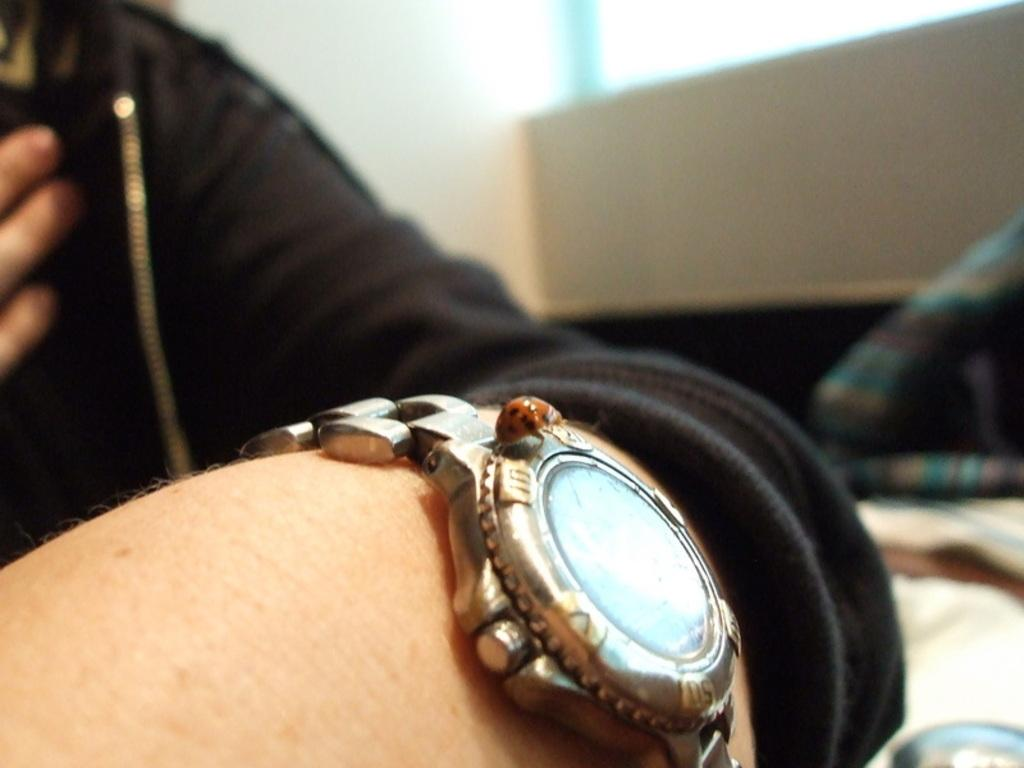Who or what is the main subject in the image? There is a person in the image. What is the person wearing in the image? The person is wearing a black color jacket. Are there any accessories visible on the person in the image? Yes, the person is wearing a watch. What is the color of the background in the image? The background of the image is white. What type of patch can be seen on the person's jacket in the image? There is no patch visible on the person's jacket in the image. 